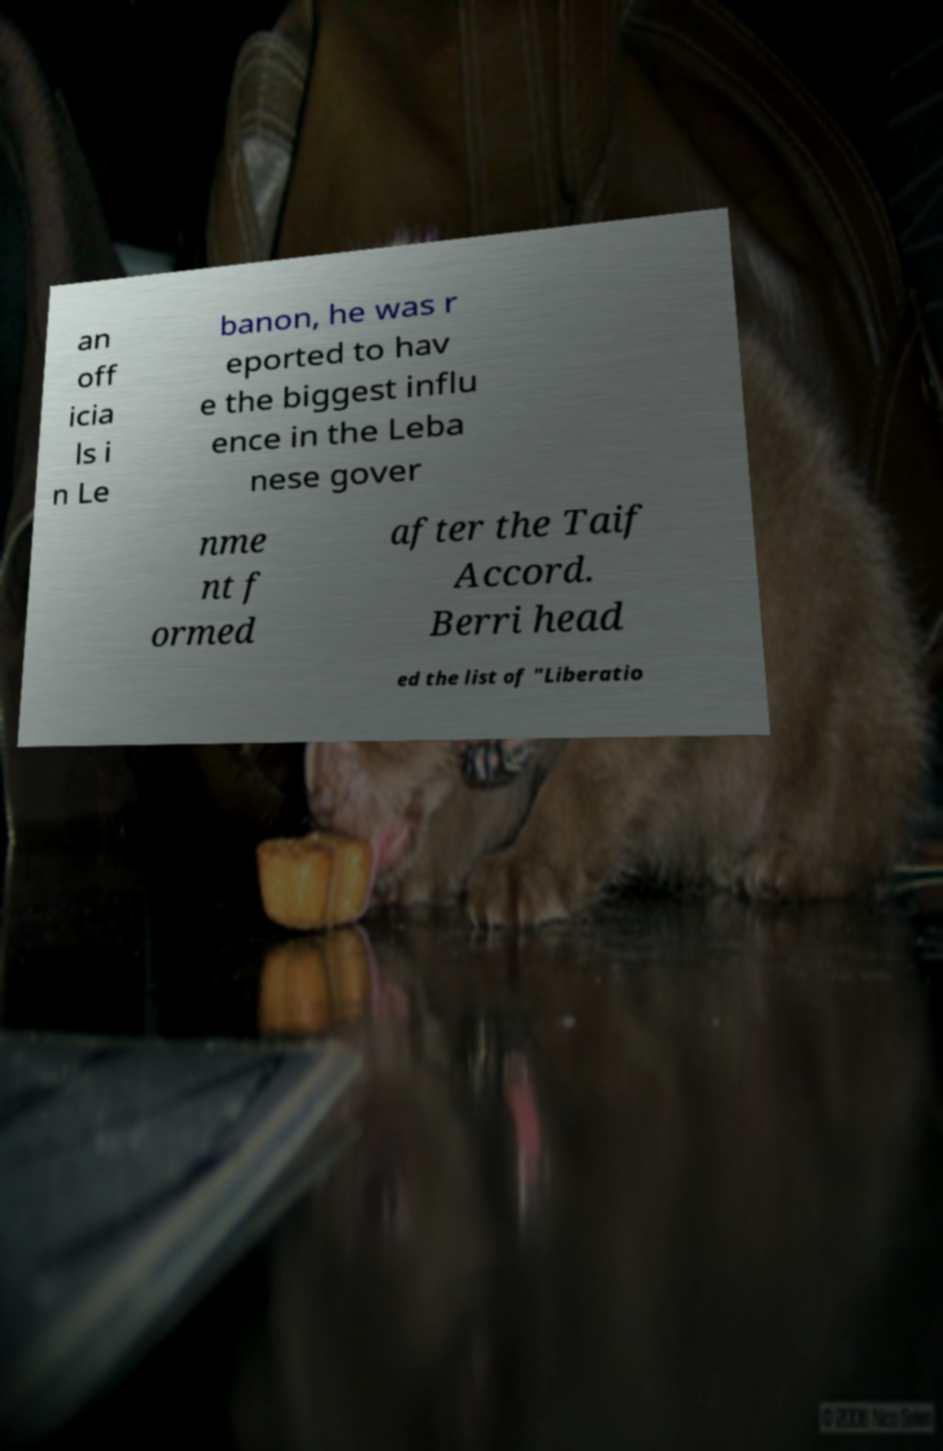Could you extract and type out the text from this image? an off icia ls i n Le banon, he was r eported to hav e the biggest influ ence in the Leba nese gover nme nt f ormed after the Taif Accord. Berri head ed the list of "Liberatio 